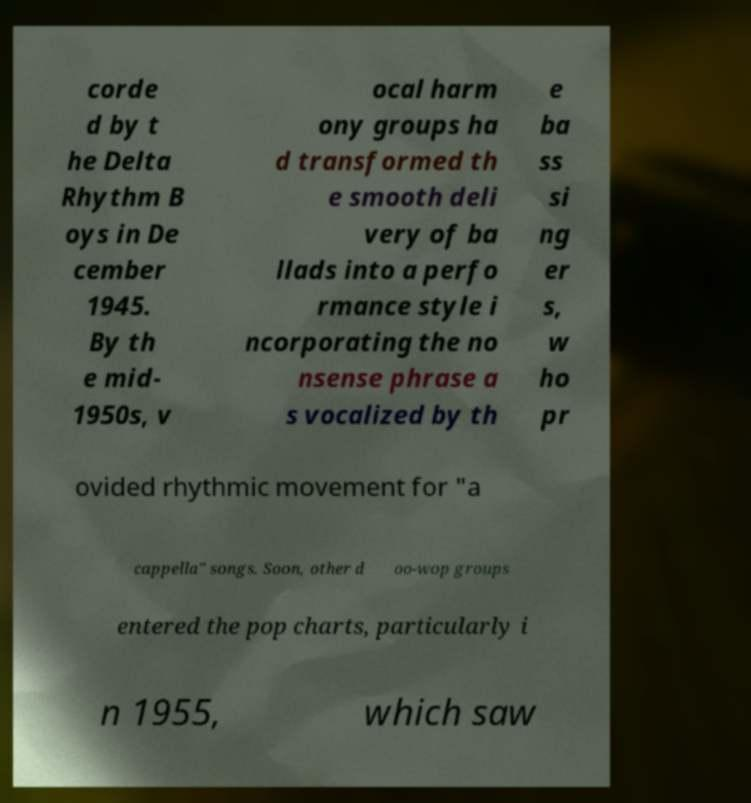Could you extract and type out the text from this image? corde d by t he Delta Rhythm B oys in De cember 1945. By th e mid- 1950s, v ocal harm ony groups ha d transformed th e smooth deli very of ba llads into a perfo rmance style i ncorporating the no nsense phrase a s vocalized by th e ba ss si ng er s, w ho pr ovided rhythmic movement for "a cappella" songs. Soon, other d oo-wop groups entered the pop charts, particularly i n 1955, which saw 